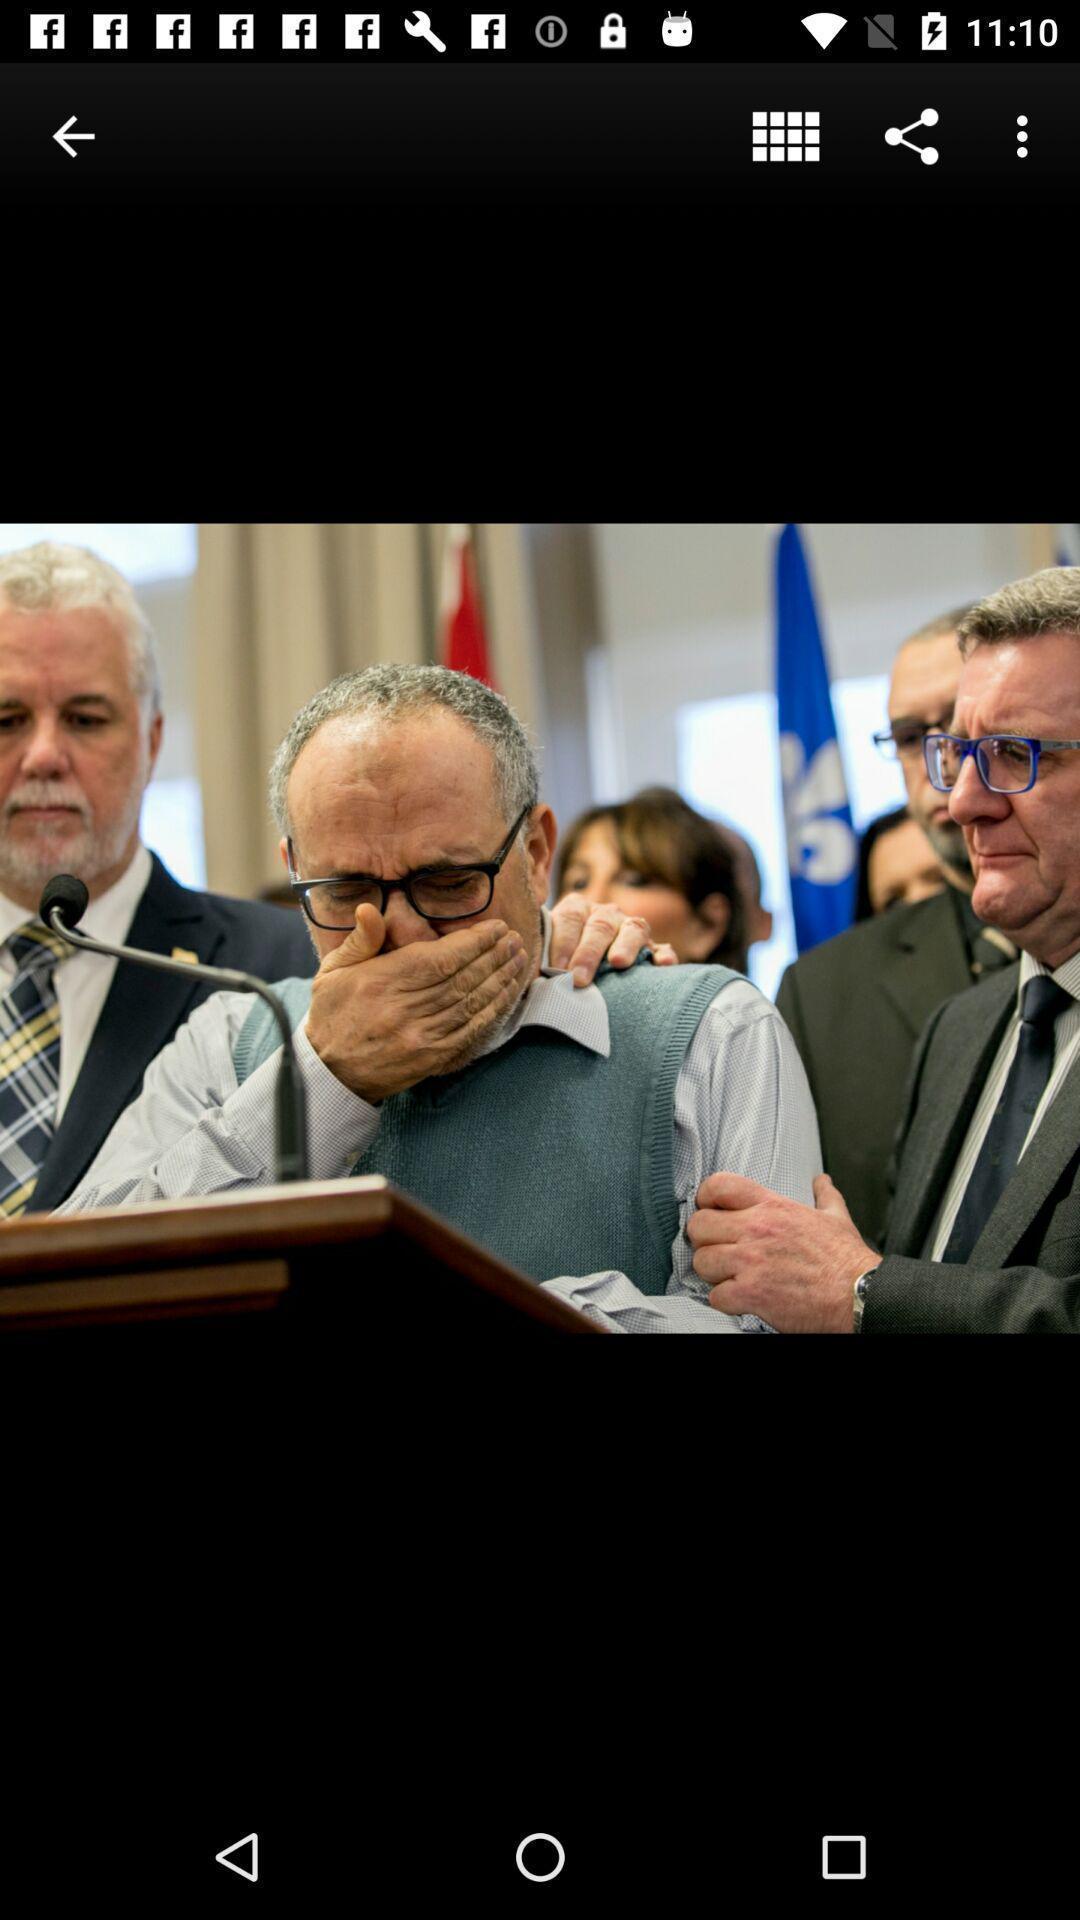What is the overall content of this screenshot? Page showing image with different options. 